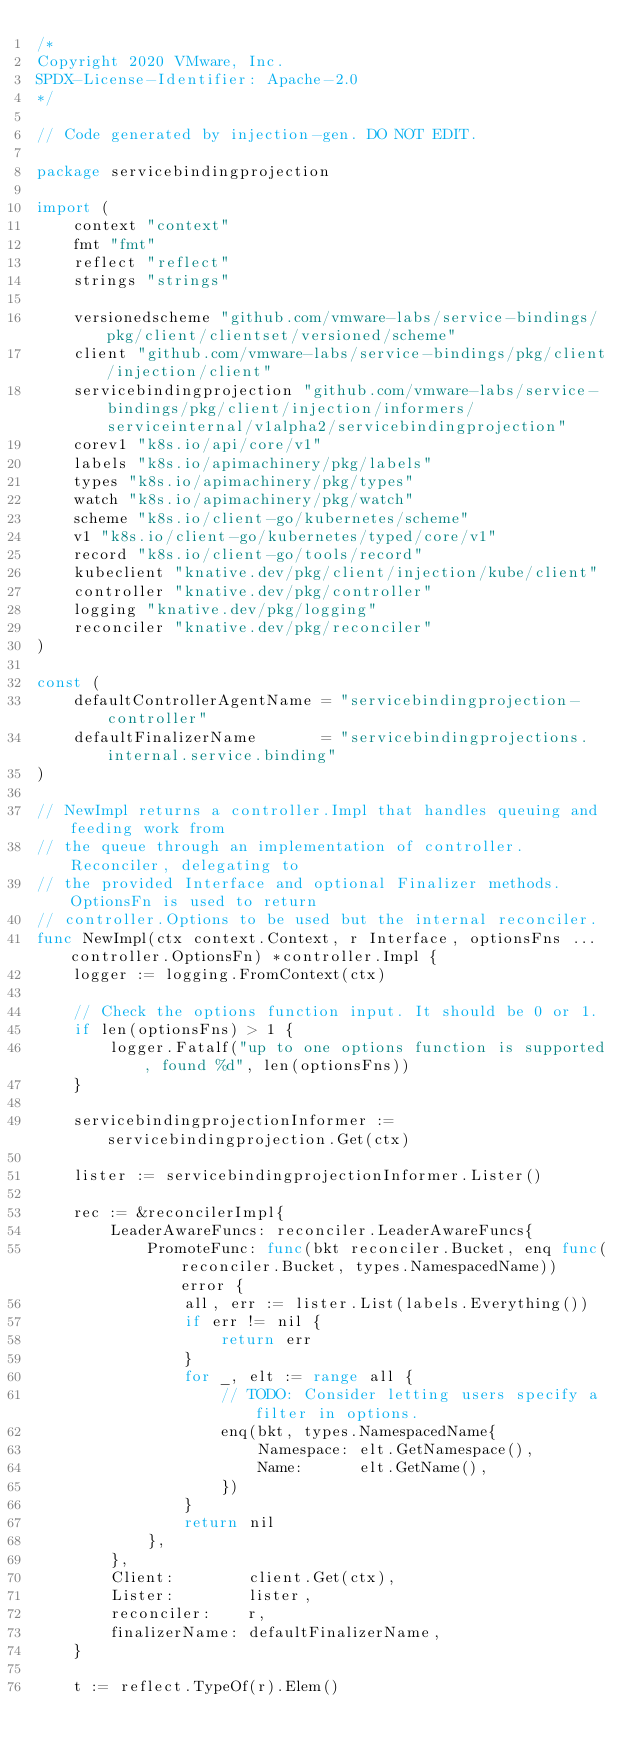<code> <loc_0><loc_0><loc_500><loc_500><_Go_>/*
Copyright 2020 VMware, Inc.
SPDX-License-Identifier: Apache-2.0
*/

// Code generated by injection-gen. DO NOT EDIT.

package servicebindingprojection

import (
	context "context"
	fmt "fmt"
	reflect "reflect"
	strings "strings"

	versionedscheme "github.com/vmware-labs/service-bindings/pkg/client/clientset/versioned/scheme"
	client "github.com/vmware-labs/service-bindings/pkg/client/injection/client"
	servicebindingprojection "github.com/vmware-labs/service-bindings/pkg/client/injection/informers/serviceinternal/v1alpha2/servicebindingprojection"
	corev1 "k8s.io/api/core/v1"
	labels "k8s.io/apimachinery/pkg/labels"
	types "k8s.io/apimachinery/pkg/types"
	watch "k8s.io/apimachinery/pkg/watch"
	scheme "k8s.io/client-go/kubernetes/scheme"
	v1 "k8s.io/client-go/kubernetes/typed/core/v1"
	record "k8s.io/client-go/tools/record"
	kubeclient "knative.dev/pkg/client/injection/kube/client"
	controller "knative.dev/pkg/controller"
	logging "knative.dev/pkg/logging"
	reconciler "knative.dev/pkg/reconciler"
)

const (
	defaultControllerAgentName = "servicebindingprojection-controller"
	defaultFinalizerName       = "servicebindingprojections.internal.service.binding"
)

// NewImpl returns a controller.Impl that handles queuing and feeding work from
// the queue through an implementation of controller.Reconciler, delegating to
// the provided Interface and optional Finalizer methods. OptionsFn is used to return
// controller.Options to be used but the internal reconciler.
func NewImpl(ctx context.Context, r Interface, optionsFns ...controller.OptionsFn) *controller.Impl {
	logger := logging.FromContext(ctx)

	// Check the options function input. It should be 0 or 1.
	if len(optionsFns) > 1 {
		logger.Fatalf("up to one options function is supported, found %d", len(optionsFns))
	}

	servicebindingprojectionInformer := servicebindingprojection.Get(ctx)

	lister := servicebindingprojectionInformer.Lister()

	rec := &reconcilerImpl{
		LeaderAwareFuncs: reconciler.LeaderAwareFuncs{
			PromoteFunc: func(bkt reconciler.Bucket, enq func(reconciler.Bucket, types.NamespacedName)) error {
				all, err := lister.List(labels.Everything())
				if err != nil {
					return err
				}
				for _, elt := range all {
					// TODO: Consider letting users specify a filter in options.
					enq(bkt, types.NamespacedName{
						Namespace: elt.GetNamespace(),
						Name:      elt.GetName(),
					})
				}
				return nil
			},
		},
		Client:        client.Get(ctx),
		Lister:        lister,
		reconciler:    r,
		finalizerName: defaultFinalizerName,
	}

	t := reflect.TypeOf(r).Elem()</code> 